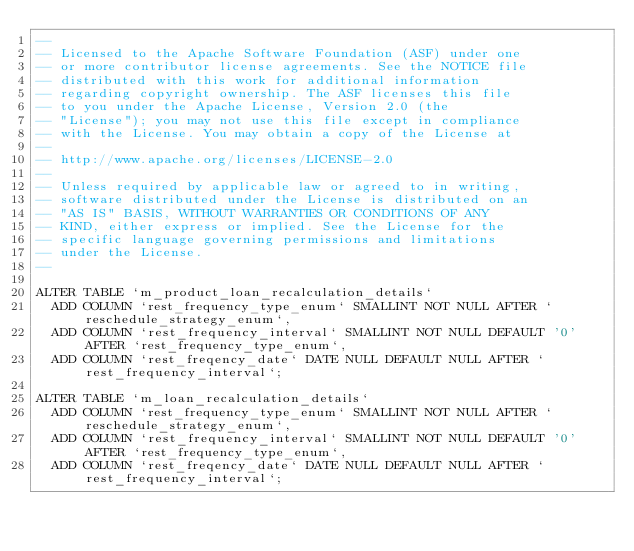<code> <loc_0><loc_0><loc_500><loc_500><_SQL_>--
-- Licensed to the Apache Software Foundation (ASF) under one
-- or more contributor license agreements. See the NOTICE file
-- distributed with this work for additional information
-- regarding copyright ownership. The ASF licenses this file
-- to you under the Apache License, Version 2.0 (the
-- "License"); you may not use this file except in compliance
-- with the License. You may obtain a copy of the License at
--
-- http://www.apache.org/licenses/LICENSE-2.0
--
-- Unless required by applicable law or agreed to in writing,
-- software distributed under the License is distributed on an
-- "AS IS" BASIS, WITHOUT WARRANTIES OR CONDITIONS OF ANY
-- KIND, either express or implied. See the License for the
-- specific language governing permissions and limitations
-- under the License.
--

ALTER TABLE `m_product_loan_recalculation_details`
	ADD COLUMN `rest_frequency_type_enum` SMALLINT NOT NULL AFTER `reschedule_strategy_enum`,
	ADD COLUMN `rest_frequency_interval` SMALLINT NOT NULL DEFAULT '0' AFTER `rest_frequency_type_enum`,
	ADD COLUMN `rest_freqency_date` DATE NULL DEFAULT NULL AFTER `rest_frequency_interval`;

ALTER TABLE `m_loan_recalculation_details`
	ADD COLUMN `rest_frequency_type_enum` SMALLINT NOT NULL AFTER `reschedule_strategy_enum`,
	ADD COLUMN `rest_frequency_interval` SMALLINT NOT NULL DEFAULT '0' AFTER `rest_frequency_type_enum`,
	ADD COLUMN `rest_freqency_date` DATE NULL DEFAULT NULL AFTER `rest_frequency_interval`;</code> 